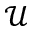Convert formula to latex. <formula><loc_0><loc_0><loc_500><loc_500>\mathcal { U }</formula> 